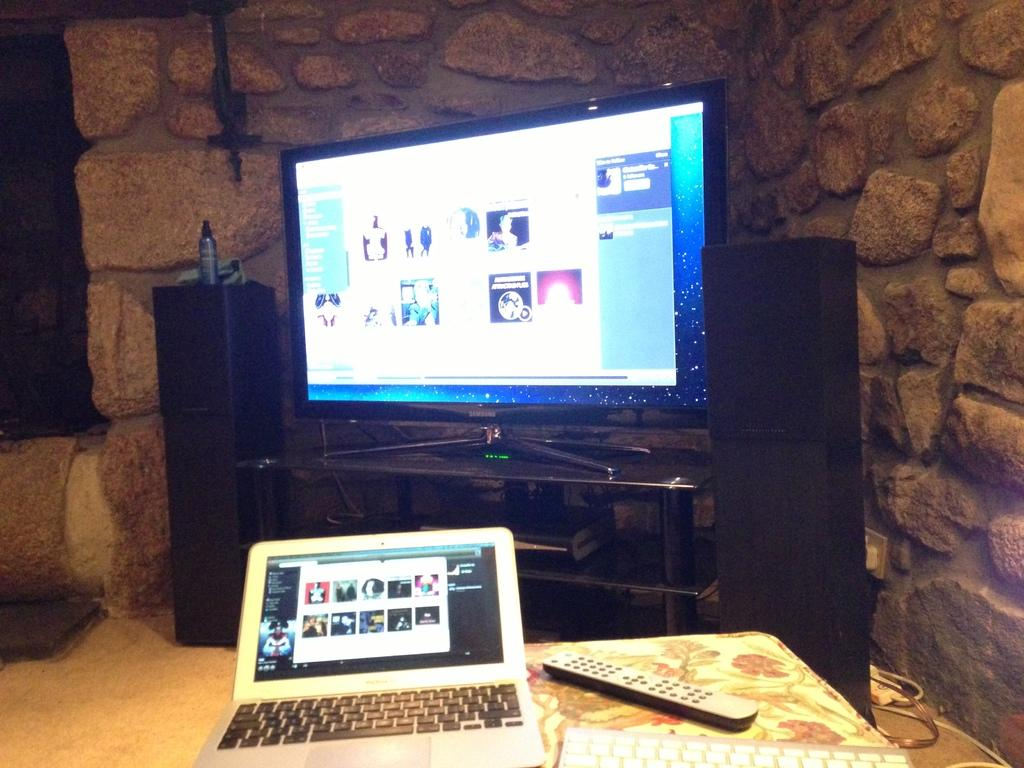What electronic device is visible in the image? There is a laptop in the image. What other device can be seen in the image? There is a remote in the image. What is used for typing in the image? There is a keyboard in the image. What is used for amplifying sound in the image? There are speakers in the image. What is the main entertainment device in the image? There is a television on a table in the image. What is visible in the background of the image? There is a wall in the background of the image. What type of drug is being administered to the patient in the image? There is no patient or drug present in the image; it features electronic devices and a television. What meal is being prepared in the image? There is no meal preparation visible in the image; it features electronic devices and a television. 